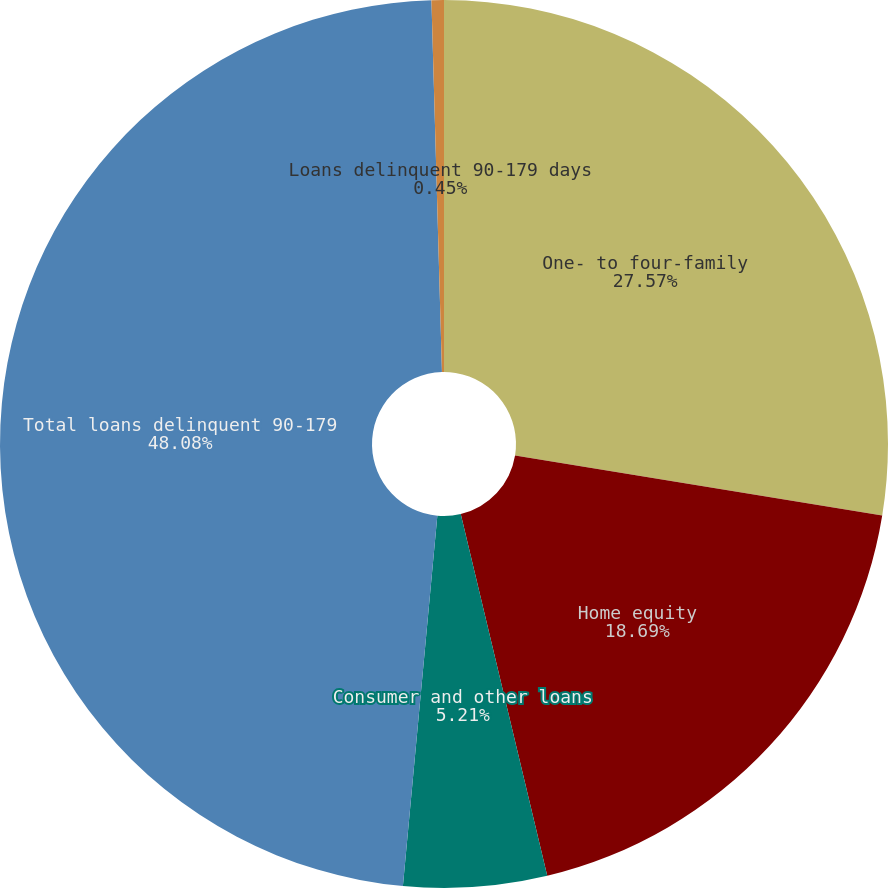Convert chart to OTSL. <chart><loc_0><loc_0><loc_500><loc_500><pie_chart><fcel>One- to four-family<fcel>Home equity<fcel>Consumer and other loans<fcel>Total loans delinquent 90-179<fcel>Loans delinquent 90-179 days<nl><fcel>27.57%<fcel>18.69%<fcel>5.21%<fcel>48.07%<fcel>0.45%<nl></chart> 